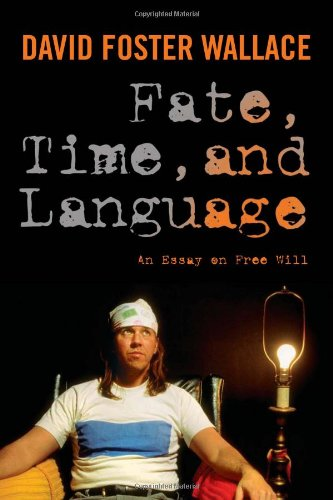Is this a sociopolitical book? Yes, this book delves into sociopolitical issues by exploring how philosophical ideas about fate and free will influence our political and social lives. 